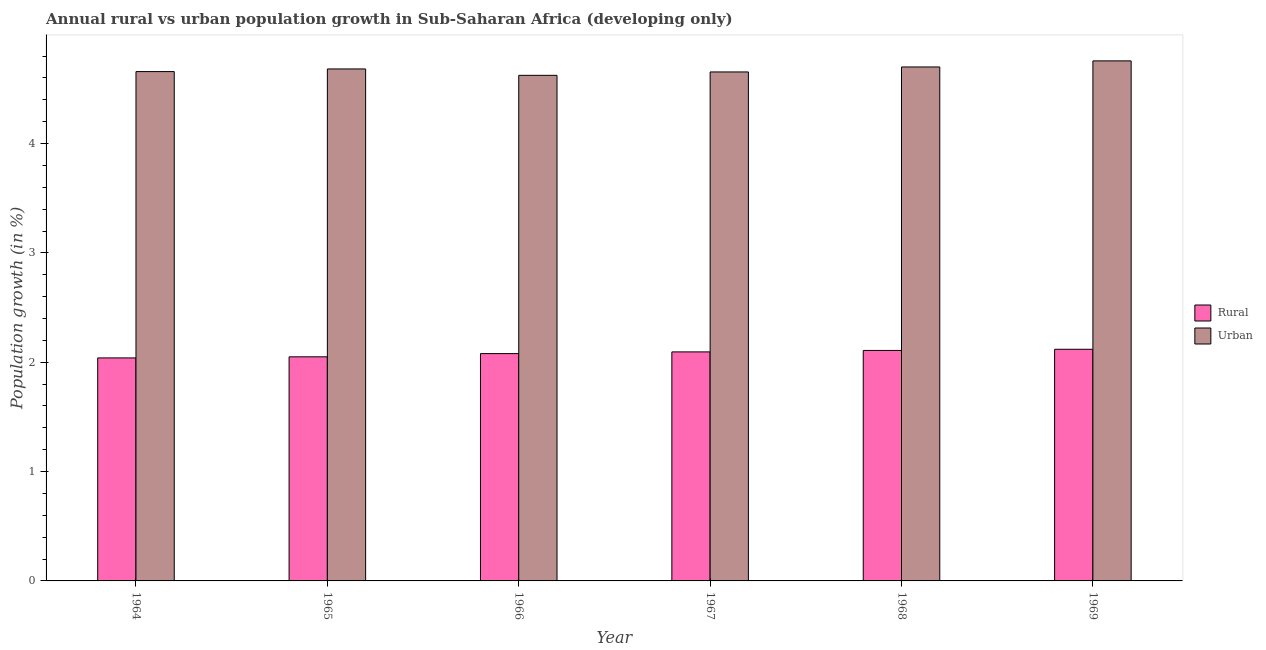How many different coloured bars are there?
Provide a short and direct response. 2. How many groups of bars are there?
Your response must be concise. 6. What is the label of the 6th group of bars from the left?
Provide a short and direct response. 1969. In how many cases, is the number of bars for a given year not equal to the number of legend labels?
Provide a short and direct response. 0. What is the urban population growth in 1967?
Give a very brief answer. 4.66. Across all years, what is the maximum urban population growth?
Offer a very short reply. 4.76. Across all years, what is the minimum rural population growth?
Offer a very short reply. 2.04. In which year was the rural population growth maximum?
Keep it short and to the point. 1969. In which year was the urban population growth minimum?
Offer a terse response. 1966. What is the total rural population growth in the graph?
Your answer should be very brief. 12.49. What is the difference between the urban population growth in 1964 and that in 1966?
Offer a terse response. 0.03. What is the difference between the urban population growth in 1966 and the rural population growth in 1969?
Give a very brief answer. -0.13. What is the average urban population growth per year?
Your response must be concise. 4.68. In the year 1967, what is the difference between the rural population growth and urban population growth?
Ensure brevity in your answer.  0. In how many years, is the rural population growth greater than 3.8 %?
Give a very brief answer. 0. What is the ratio of the urban population growth in 1965 to that in 1966?
Your answer should be very brief. 1.01. Is the difference between the urban population growth in 1964 and 1967 greater than the difference between the rural population growth in 1964 and 1967?
Your answer should be compact. No. What is the difference between the highest and the second highest rural population growth?
Ensure brevity in your answer.  0.01. What is the difference between the highest and the lowest rural population growth?
Make the answer very short. 0.08. In how many years, is the rural population growth greater than the average rural population growth taken over all years?
Your answer should be very brief. 3. Is the sum of the rural population growth in 1966 and 1969 greater than the maximum urban population growth across all years?
Make the answer very short. Yes. What does the 1st bar from the left in 1968 represents?
Ensure brevity in your answer.  Rural. What does the 1st bar from the right in 1968 represents?
Give a very brief answer. Urban . How many bars are there?
Ensure brevity in your answer.  12. Are all the bars in the graph horizontal?
Your answer should be compact. No. How many years are there in the graph?
Offer a terse response. 6. Are the values on the major ticks of Y-axis written in scientific E-notation?
Keep it short and to the point. No. Where does the legend appear in the graph?
Your response must be concise. Center right. How many legend labels are there?
Provide a short and direct response. 2. How are the legend labels stacked?
Your answer should be compact. Vertical. What is the title of the graph?
Keep it short and to the point. Annual rural vs urban population growth in Sub-Saharan Africa (developing only). Does "Export" appear as one of the legend labels in the graph?
Give a very brief answer. No. What is the label or title of the X-axis?
Offer a very short reply. Year. What is the label or title of the Y-axis?
Offer a terse response. Population growth (in %). What is the Population growth (in %) in Rural in 1964?
Offer a terse response. 2.04. What is the Population growth (in %) in Urban  in 1964?
Your answer should be compact. 4.66. What is the Population growth (in %) of Rural in 1965?
Your response must be concise. 2.05. What is the Population growth (in %) of Urban  in 1965?
Ensure brevity in your answer.  4.68. What is the Population growth (in %) in Rural in 1966?
Offer a very short reply. 2.08. What is the Population growth (in %) in Urban  in 1966?
Make the answer very short. 4.62. What is the Population growth (in %) of Rural in 1967?
Your answer should be compact. 2.09. What is the Population growth (in %) of Urban  in 1967?
Ensure brevity in your answer.  4.66. What is the Population growth (in %) in Rural in 1968?
Ensure brevity in your answer.  2.11. What is the Population growth (in %) of Urban  in 1968?
Offer a terse response. 4.7. What is the Population growth (in %) in Rural in 1969?
Provide a short and direct response. 2.12. What is the Population growth (in %) of Urban  in 1969?
Your answer should be very brief. 4.76. Across all years, what is the maximum Population growth (in %) of Rural?
Make the answer very short. 2.12. Across all years, what is the maximum Population growth (in %) of Urban ?
Your response must be concise. 4.76. Across all years, what is the minimum Population growth (in %) of Rural?
Keep it short and to the point. 2.04. Across all years, what is the minimum Population growth (in %) in Urban ?
Provide a short and direct response. 4.62. What is the total Population growth (in %) of Rural in the graph?
Your response must be concise. 12.49. What is the total Population growth (in %) in Urban  in the graph?
Keep it short and to the point. 28.08. What is the difference between the Population growth (in %) in Rural in 1964 and that in 1965?
Provide a succinct answer. -0.01. What is the difference between the Population growth (in %) in Urban  in 1964 and that in 1965?
Offer a very short reply. -0.02. What is the difference between the Population growth (in %) of Rural in 1964 and that in 1966?
Offer a terse response. -0.04. What is the difference between the Population growth (in %) of Urban  in 1964 and that in 1966?
Provide a short and direct response. 0.03. What is the difference between the Population growth (in %) of Rural in 1964 and that in 1967?
Keep it short and to the point. -0.06. What is the difference between the Population growth (in %) of Urban  in 1964 and that in 1967?
Ensure brevity in your answer.  0. What is the difference between the Population growth (in %) in Rural in 1964 and that in 1968?
Give a very brief answer. -0.07. What is the difference between the Population growth (in %) of Urban  in 1964 and that in 1968?
Give a very brief answer. -0.04. What is the difference between the Population growth (in %) in Rural in 1964 and that in 1969?
Your answer should be compact. -0.08. What is the difference between the Population growth (in %) of Urban  in 1964 and that in 1969?
Make the answer very short. -0.1. What is the difference between the Population growth (in %) in Rural in 1965 and that in 1966?
Your answer should be very brief. -0.03. What is the difference between the Population growth (in %) of Urban  in 1965 and that in 1966?
Provide a short and direct response. 0.06. What is the difference between the Population growth (in %) of Rural in 1965 and that in 1967?
Your answer should be compact. -0.05. What is the difference between the Population growth (in %) of Urban  in 1965 and that in 1967?
Make the answer very short. 0.03. What is the difference between the Population growth (in %) in Rural in 1965 and that in 1968?
Offer a very short reply. -0.06. What is the difference between the Population growth (in %) in Urban  in 1965 and that in 1968?
Your answer should be compact. -0.02. What is the difference between the Population growth (in %) in Rural in 1965 and that in 1969?
Ensure brevity in your answer.  -0.07. What is the difference between the Population growth (in %) of Urban  in 1965 and that in 1969?
Provide a succinct answer. -0.07. What is the difference between the Population growth (in %) in Rural in 1966 and that in 1967?
Your answer should be compact. -0.02. What is the difference between the Population growth (in %) of Urban  in 1966 and that in 1967?
Offer a very short reply. -0.03. What is the difference between the Population growth (in %) in Rural in 1966 and that in 1968?
Offer a terse response. -0.03. What is the difference between the Population growth (in %) of Urban  in 1966 and that in 1968?
Your response must be concise. -0.08. What is the difference between the Population growth (in %) in Rural in 1966 and that in 1969?
Make the answer very short. -0.04. What is the difference between the Population growth (in %) in Urban  in 1966 and that in 1969?
Your answer should be compact. -0.13. What is the difference between the Population growth (in %) in Rural in 1967 and that in 1968?
Provide a short and direct response. -0.01. What is the difference between the Population growth (in %) of Urban  in 1967 and that in 1968?
Make the answer very short. -0.05. What is the difference between the Population growth (in %) of Rural in 1967 and that in 1969?
Keep it short and to the point. -0.02. What is the difference between the Population growth (in %) in Urban  in 1967 and that in 1969?
Keep it short and to the point. -0.1. What is the difference between the Population growth (in %) of Rural in 1968 and that in 1969?
Provide a short and direct response. -0.01. What is the difference between the Population growth (in %) of Urban  in 1968 and that in 1969?
Give a very brief answer. -0.06. What is the difference between the Population growth (in %) of Rural in 1964 and the Population growth (in %) of Urban  in 1965?
Ensure brevity in your answer.  -2.64. What is the difference between the Population growth (in %) in Rural in 1964 and the Population growth (in %) in Urban  in 1966?
Offer a very short reply. -2.58. What is the difference between the Population growth (in %) in Rural in 1964 and the Population growth (in %) in Urban  in 1967?
Provide a short and direct response. -2.62. What is the difference between the Population growth (in %) in Rural in 1964 and the Population growth (in %) in Urban  in 1968?
Provide a short and direct response. -2.66. What is the difference between the Population growth (in %) in Rural in 1964 and the Population growth (in %) in Urban  in 1969?
Offer a terse response. -2.72. What is the difference between the Population growth (in %) in Rural in 1965 and the Population growth (in %) in Urban  in 1966?
Give a very brief answer. -2.57. What is the difference between the Population growth (in %) of Rural in 1965 and the Population growth (in %) of Urban  in 1967?
Ensure brevity in your answer.  -2.61. What is the difference between the Population growth (in %) of Rural in 1965 and the Population growth (in %) of Urban  in 1968?
Ensure brevity in your answer.  -2.65. What is the difference between the Population growth (in %) of Rural in 1965 and the Population growth (in %) of Urban  in 1969?
Your answer should be very brief. -2.71. What is the difference between the Population growth (in %) in Rural in 1966 and the Population growth (in %) in Urban  in 1967?
Give a very brief answer. -2.58. What is the difference between the Population growth (in %) of Rural in 1966 and the Population growth (in %) of Urban  in 1968?
Offer a terse response. -2.62. What is the difference between the Population growth (in %) of Rural in 1966 and the Population growth (in %) of Urban  in 1969?
Your response must be concise. -2.68. What is the difference between the Population growth (in %) of Rural in 1967 and the Population growth (in %) of Urban  in 1968?
Offer a very short reply. -2.61. What is the difference between the Population growth (in %) of Rural in 1967 and the Population growth (in %) of Urban  in 1969?
Give a very brief answer. -2.66. What is the difference between the Population growth (in %) in Rural in 1968 and the Population growth (in %) in Urban  in 1969?
Your response must be concise. -2.65. What is the average Population growth (in %) in Rural per year?
Offer a very short reply. 2.08. What is the average Population growth (in %) in Urban  per year?
Offer a very short reply. 4.68. In the year 1964, what is the difference between the Population growth (in %) of Rural and Population growth (in %) of Urban ?
Offer a terse response. -2.62. In the year 1965, what is the difference between the Population growth (in %) of Rural and Population growth (in %) of Urban ?
Ensure brevity in your answer.  -2.63. In the year 1966, what is the difference between the Population growth (in %) in Rural and Population growth (in %) in Urban ?
Offer a very short reply. -2.54. In the year 1967, what is the difference between the Population growth (in %) in Rural and Population growth (in %) in Urban ?
Ensure brevity in your answer.  -2.56. In the year 1968, what is the difference between the Population growth (in %) of Rural and Population growth (in %) of Urban ?
Keep it short and to the point. -2.59. In the year 1969, what is the difference between the Population growth (in %) in Rural and Population growth (in %) in Urban ?
Your answer should be compact. -2.64. What is the ratio of the Population growth (in %) of Rural in 1964 to that in 1965?
Offer a terse response. 1. What is the ratio of the Population growth (in %) in Urban  in 1964 to that in 1966?
Your answer should be compact. 1.01. What is the ratio of the Population growth (in %) of Rural in 1964 to that in 1967?
Keep it short and to the point. 0.97. What is the ratio of the Population growth (in %) in Rural in 1964 to that in 1968?
Make the answer very short. 0.97. What is the ratio of the Population growth (in %) in Rural in 1964 to that in 1969?
Offer a terse response. 0.96. What is the ratio of the Population growth (in %) of Urban  in 1964 to that in 1969?
Give a very brief answer. 0.98. What is the ratio of the Population growth (in %) in Rural in 1965 to that in 1966?
Make the answer very short. 0.99. What is the ratio of the Population growth (in %) in Urban  in 1965 to that in 1966?
Make the answer very short. 1.01. What is the ratio of the Population growth (in %) in Rural in 1965 to that in 1967?
Offer a terse response. 0.98. What is the ratio of the Population growth (in %) of Urban  in 1965 to that in 1967?
Provide a succinct answer. 1.01. What is the ratio of the Population growth (in %) of Rural in 1965 to that in 1968?
Provide a succinct answer. 0.97. What is the ratio of the Population growth (in %) in Rural in 1965 to that in 1969?
Provide a short and direct response. 0.97. What is the ratio of the Population growth (in %) in Urban  in 1965 to that in 1969?
Provide a short and direct response. 0.98. What is the ratio of the Population growth (in %) of Rural in 1966 to that in 1967?
Keep it short and to the point. 0.99. What is the ratio of the Population growth (in %) of Urban  in 1966 to that in 1967?
Give a very brief answer. 0.99. What is the ratio of the Population growth (in %) in Rural in 1966 to that in 1968?
Your response must be concise. 0.99. What is the ratio of the Population growth (in %) of Urban  in 1966 to that in 1968?
Your response must be concise. 0.98. What is the ratio of the Population growth (in %) of Rural in 1966 to that in 1969?
Your answer should be compact. 0.98. What is the ratio of the Population growth (in %) of Urban  in 1966 to that in 1969?
Your answer should be compact. 0.97. What is the ratio of the Population growth (in %) of Urban  in 1967 to that in 1968?
Keep it short and to the point. 0.99. What is the ratio of the Population growth (in %) in Rural in 1967 to that in 1969?
Offer a terse response. 0.99. What is the ratio of the Population growth (in %) in Urban  in 1967 to that in 1969?
Provide a succinct answer. 0.98. What is the ratio of the Population growth (in %) of Urban  in 1968 to that in 1969?
Offer a very short reply. 0.99. What is the difference between the highest and the second highest Population growth (in %) in Rural?
Your answer should be compact. 0.01. What is the difference between the highest and the second highest Population growth (in %) in Urban ?
Provide a succinct answer. 0.06. What is the difference between the highest and the lowest Population growth (in %) in Rural?
Offer a terse response. 0.08. What is the difference between the highest and the lowest Population growth (in %) of Urban ?
Provide a succinct answer. 0.13. 